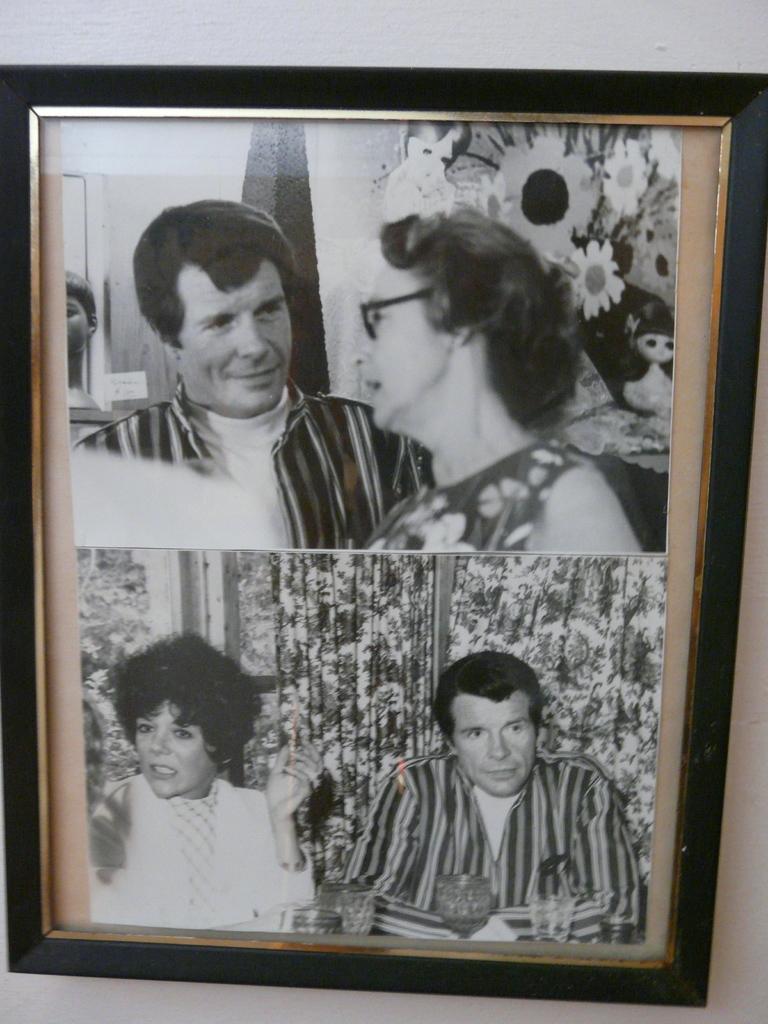Please provide a concise description of this image. In this image there is a photo frame with black borders. In the photo frame there are two photographs of a man and a woman. 